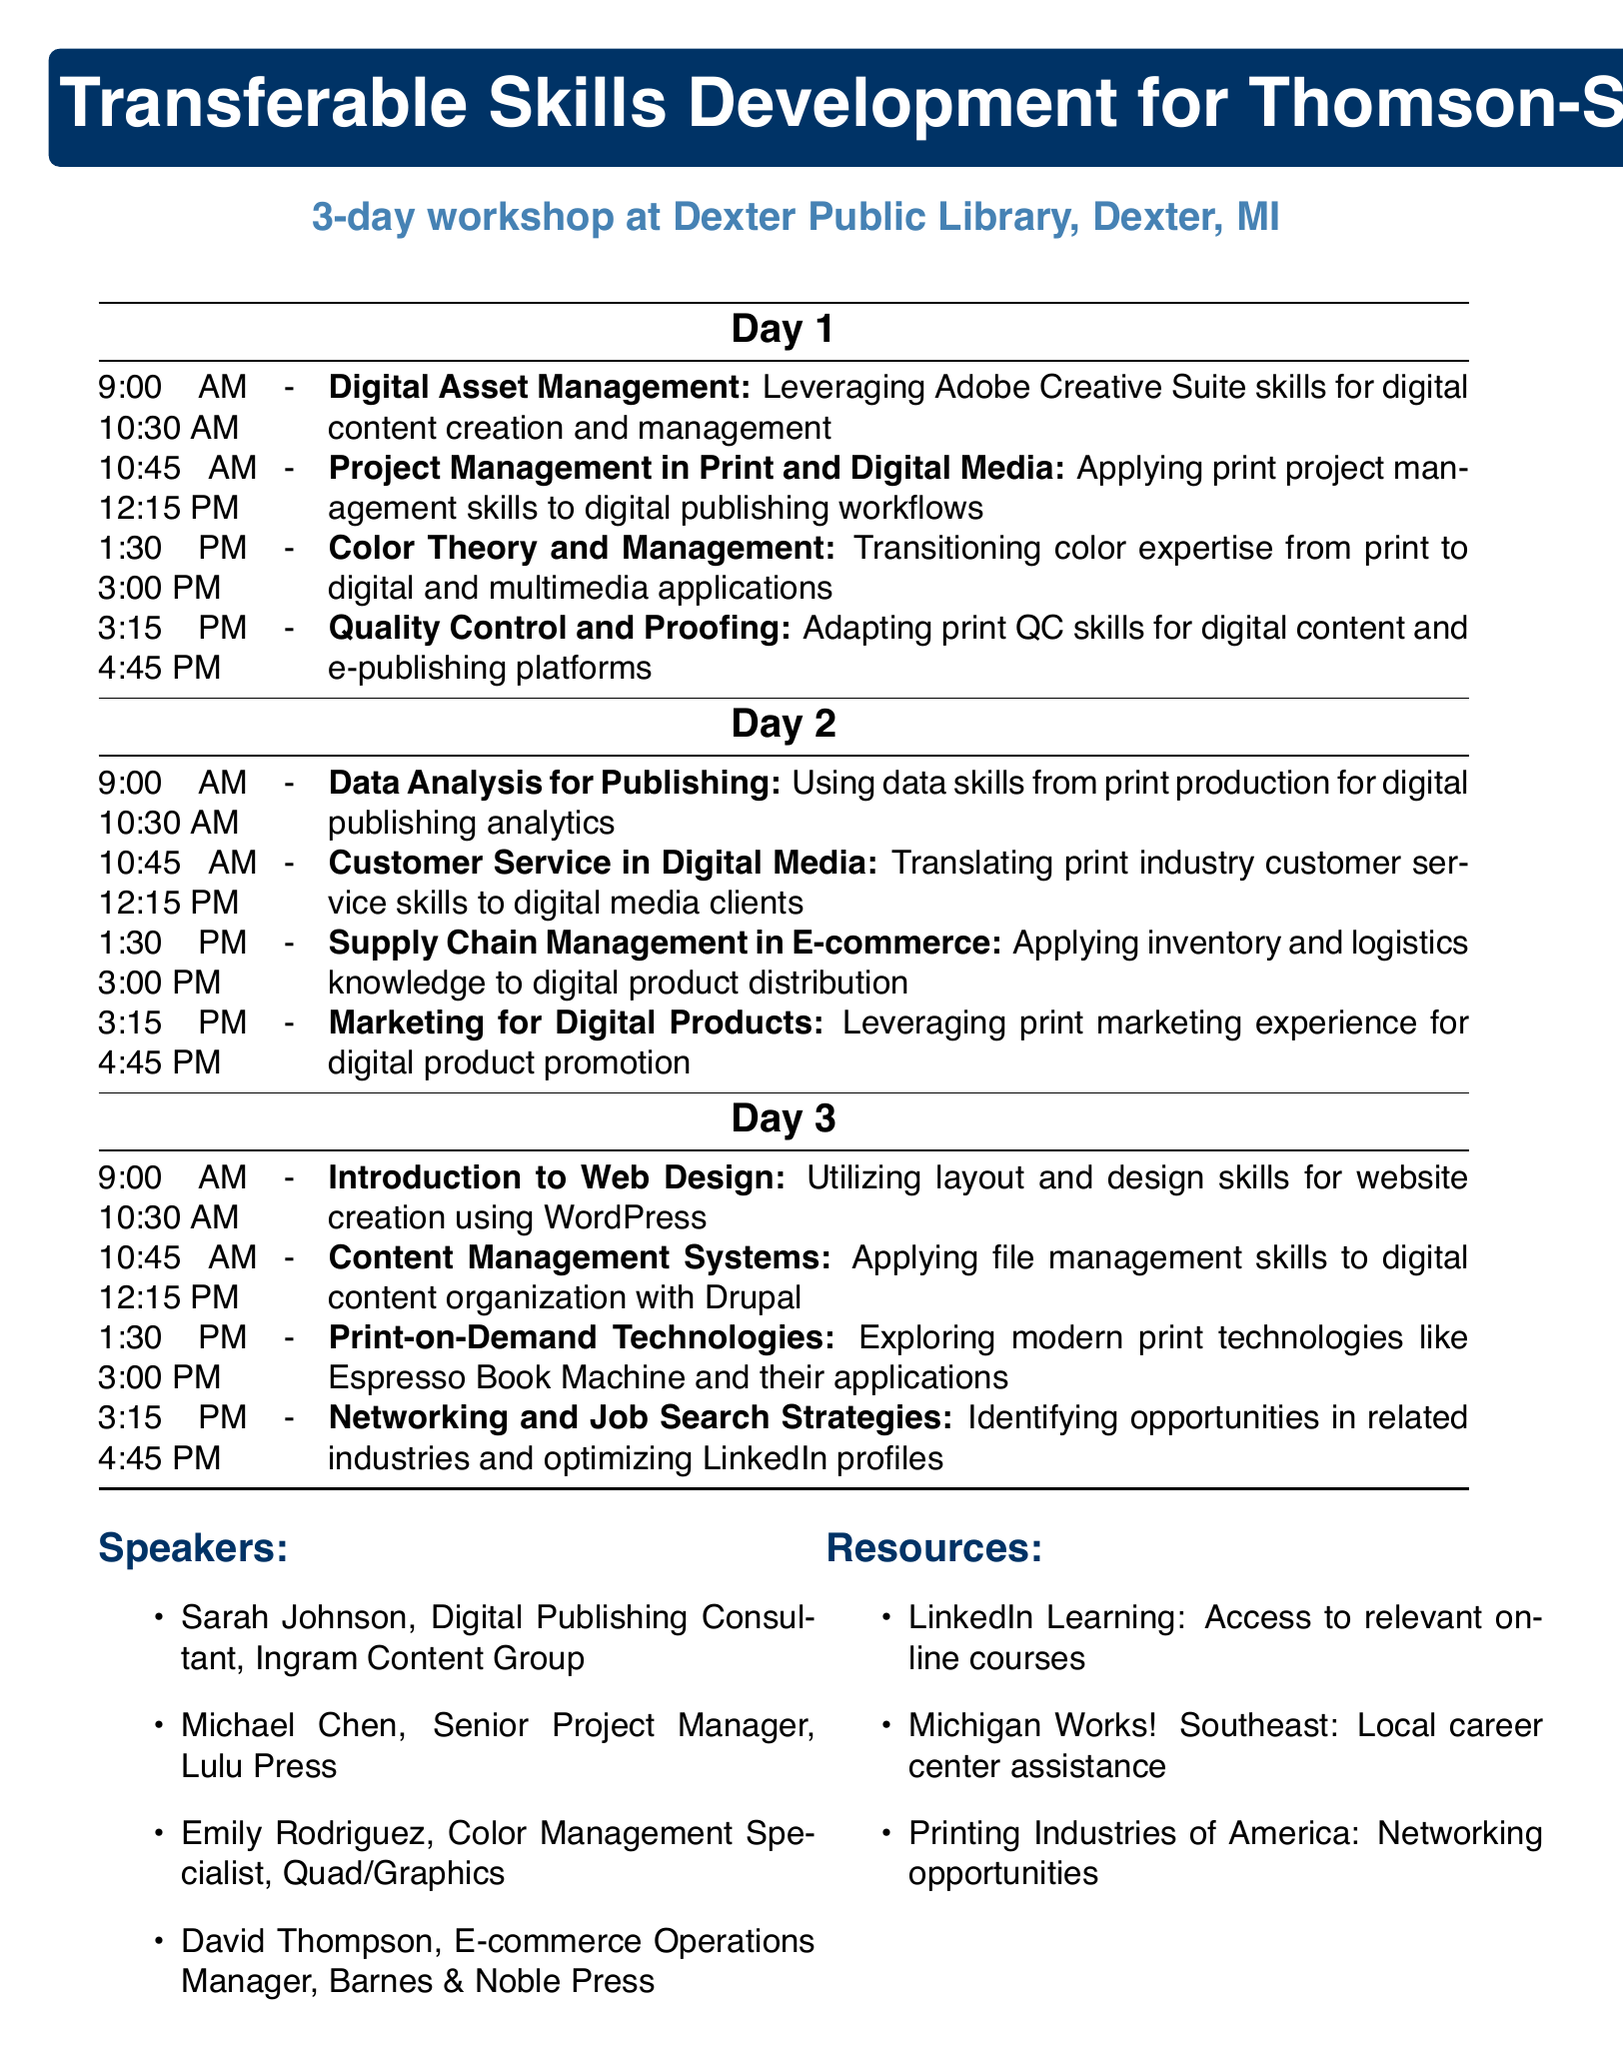What is the title of the workshop? The title of the workshop is mentioned at the beginning of the document as "Transferable Skills Development for Thomson-Shore Print Professionals."
Answer: Transferable Skills Development for Thomson-Shore Print Professionals Where is the workshop located? The location of the workshop is provided in the document as "Dexter Public Library, Dexter, MI."
Answer: Dexter Public Library, Dexter, MI How many days does the workshop last? The document states the duration of the workshop as a "3-day workshop."
Answer: 3-day workshop What session covers "Digital Asset Management"? The time and topic for "Digital Asset Management" are provided in the schedule under Day 1.
Answer: 9:00 AM - 10:30 AM Who is speaking on Day 2 about Customer Service? The speaker's name and title for the session on customer service is included in the list of speakers.
Answer: David Thompson What is included in the resources section? The resources section lists three specific resources for participants to access for additional help or information.
Answer: LinkedIn Learning, Michigan Works! Southeast, Printing Industries of America What time does the session on "Print-on-Demand Technologies" start? The document specifies the timing for the session on "Print-on-Demand Technologies" in the Day 3 schedule.
Answer: 1:30 PM How many sessions are scheduled on Day 3? The document outlines the total number of sessions scheduled for the third day.
Answer: Four sessions 